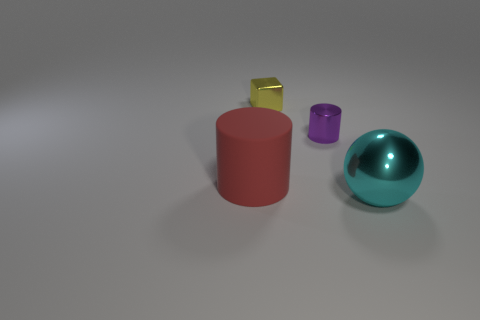Is there anything else that has the same shape as the large shiny object?
Make the answer very short. No. How many rubber things are small blue balls or big balls?
Your response must be concise. 0. How many big cylinders have the same color as the large metallic sphere?
Provide a short and direct response. 0. There is a cylinder that is to the right of the large object on the left side of the sphere; what is its material?
Your response must be concise. Metal. What is the size of the red rubber cylinder?
Your answer should be very brief. Large. What number of yellow shiny objects have the same size as the cyan ball?
Your answer should be very brief. 0. What number of tiny purple objects have the same shape as the big cyan object?
Your answer should be compact. 0. Are there an equal number of tiny purple metallic objects that are on the right side of the large matte cylinder and cyan things?
Provide a short and direct response. Yes. What shape is the metallic object that is the same size as the purple metallic cylinder?
Make the answer very short. Cube. Is there a tiny purple shiny object of the same shape as the red thing?
Give a very brief answer. Yes. 